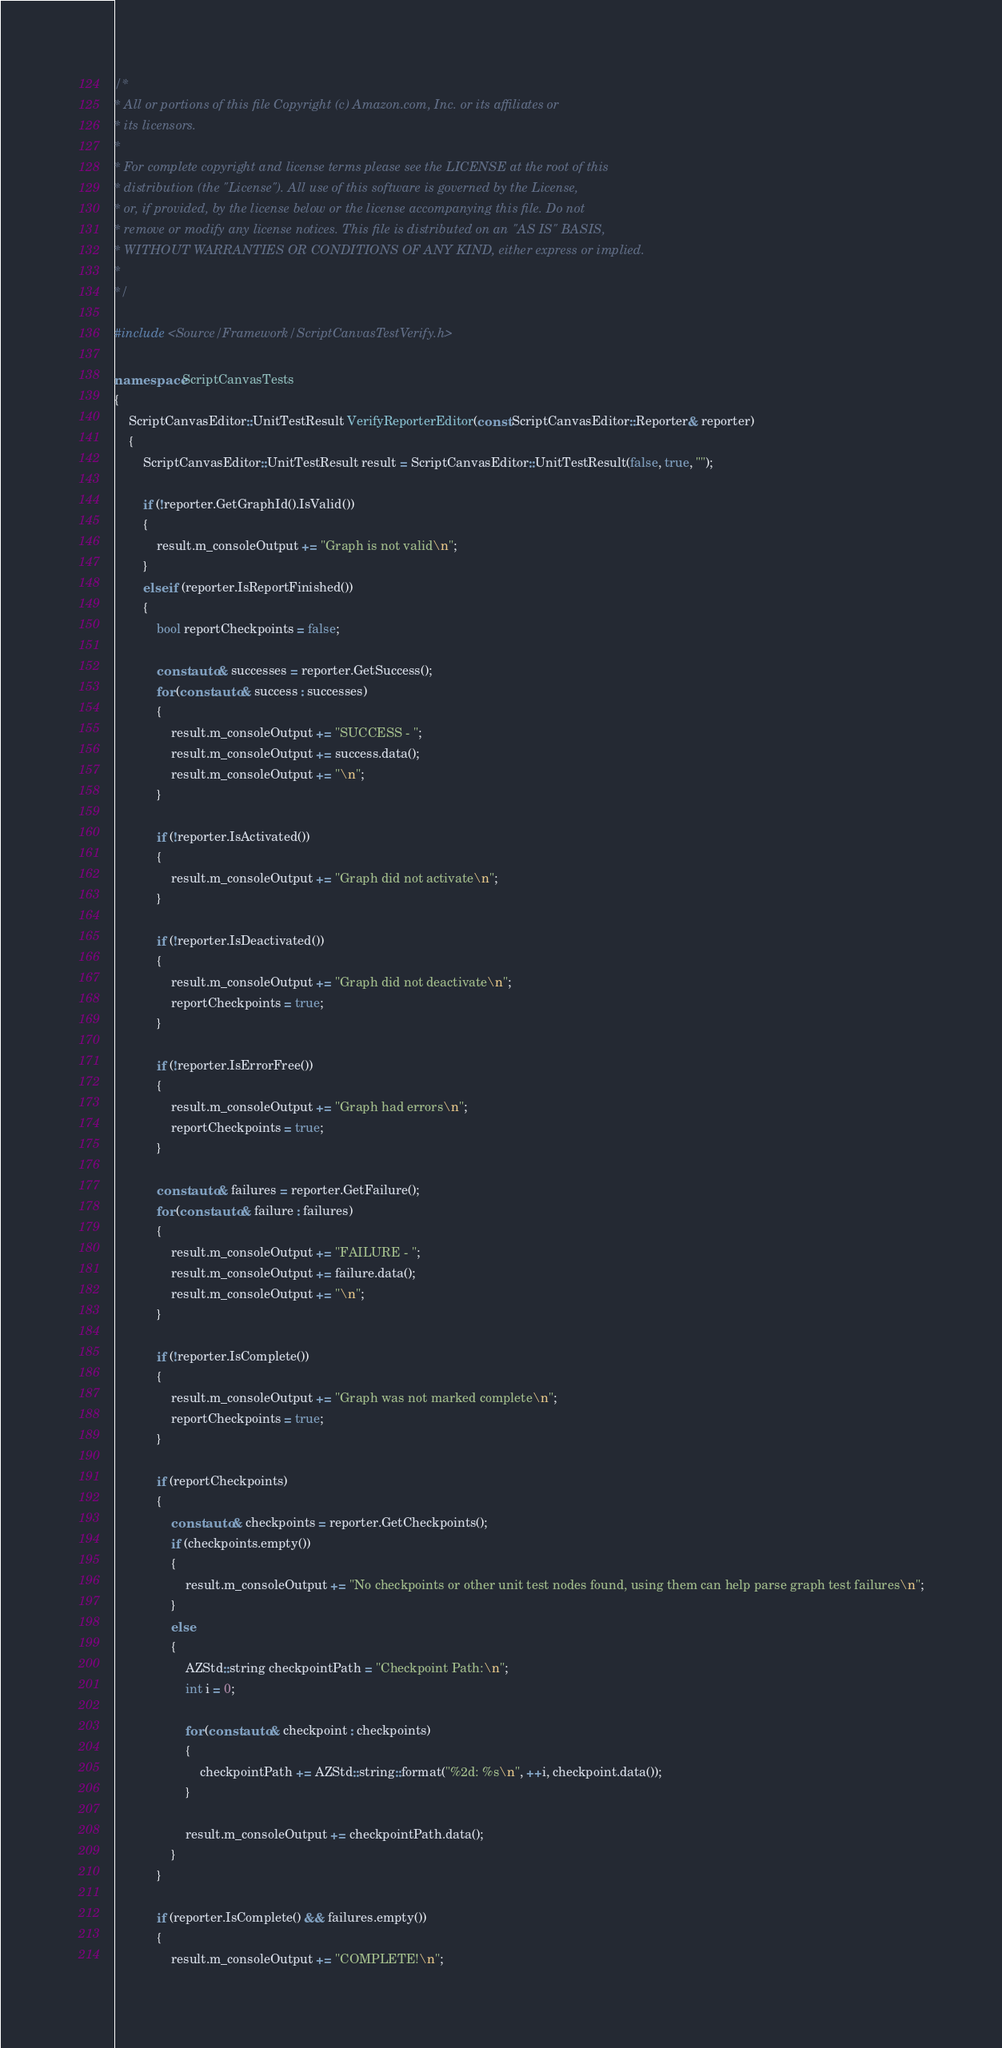<code> <loc_0><loc_0><loc_500><loc_500><_C++_>/*
* All or portions of this file Copyright (c) Amazon.com, Inc. or its affiliates or
* its licensors.
*
* For complete copyright and license terms please see the LICENSE at the root of this
* distribution (the "License"). All use of this software is governed by the License,
* or, if provided, by the license below or the license accompanying this file. Do not
* remove or modify any license notices. This file is distributed on an "AS IS" BASIS,
* WITHOUT WARRANTIES OR CONDITIONS OF ANY KIND, either express or implied.
*
*/

#include <Source/Framework/ScriptCanvasTestVerify.h>

namespace ScriptCanvasTests
{
    ScriptCanvasEditor::UnitTestResult VerifyReporterEditor(const ScriptCanvasEditor::Reporter& reporter)
    {
        ScriptCanvasEditor::UnitTestResult result = ScriptCanvasEditor::UnitTestResult(false, true, "");

        if (!reporter.GetGraphId().IsValid())
        {
            result.m_consoleOutput += "Graph is not valid\n";
        }
        else if (reporter.IsReportFinished())
        {
            bool reportCheckpoints = false;

            const auto& successes = reporter.GetSuccess();
            for (const auto& success : successes)
            {
                result.m_consoleOutput += "SUCCESS - ";
                result.m_consoleOutput += success.data();
                result.m_consoleOutput += "\n";
            }

            if (!reporter.IsActivated())
            {
                result.m_consoleOutput += "Graph did not activate\n";
            }

            if (!reporter.IsDeactivated())
            {
                result.m_consoleOutput += "Graph did not deactivate\n";
                reportCheckpoints = true;
            }

            if (!reporter.IsErrorFree())
            {
                result.m_consoleOutput += "Graph had errors\n";
                reportCheckpoints = true;
            }

            const auto& failures = reporter.GetFailure();
            for (const auto& failure : failures)
            {
                result.m_consoleOutput += "FAILURE - ";
                result.m_consoleOutput += failure.data();
                result.m_consoleOutput += "\n";
            }

            if (!reporter.IsComplete())
            {
                result.m_consoleOutput += "Graph was not marked complete\n";
                reportCheckpoints = true;
            }

            if (reportCheckpoints)
            {
                const auto& checkpoints = reporter.GetCheckpoints();
                if (checkpoints.empty())
                {
                    result.m_consoleOutput += "No checkpoints or other unit test nodes found, using them can help parse graph test failures\n";
                }
                else
                {
                    AZStd::string checkpointPath = "Checkpoint Path:\n";
                    int i = 0;

                    for (const auto& checkpoint : checkpoints)
                    {
                        checkpointPath += AZStd::string::format("%2d: %s\n", ++i, checkpoint.data());
                    }

                    result.m_consoleOutput += checkpointPath.data();
                }
            }

            if (reporter.IsComplete() && failures.empty())
            {
                result.m_consoleOutput += "COMPLETE!\n";</code> 